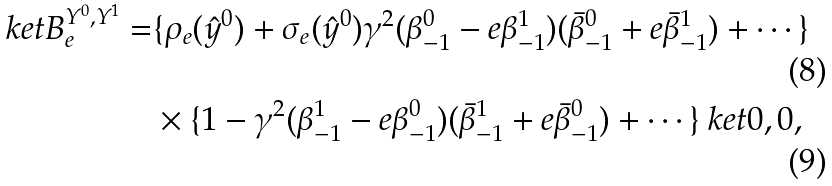<formula> <loc_0><loc_0><loc_500><loc_500>\ k e t { B } _ { e } ^ { Y ^ { 0 } , Y ^ { 1 } } = & \{ \rho _ { e } ( \hat { y } ^ { 0 } ) + \sigma _ { e } ( \hat { y } ^ { 0 } ) \gamma ^ { 2 } ( \beta _ { - 1 } ^ { 0 } - e \beta _ { - 1 } ^ { 1 } ) ( \bar { \beta } _ { - 1 } ^ { 0 } + e \bar { \beta } _ { - 1 } ^ { 1 } ) + \cdots \} \\ & \times \{ 1 - \gamma ^ { 2 } ( \beta _ { - 1 } ^ { 1 } - e \beta _ { - 1 } ^ { 0 } ) ( \bar { \beta } _ { - 1 } ^ { 1 } + e \bar { \beta } _ { - 1 } ^ { 0 } ) + \cdots \} \ k e t { 0 , 0 } ,</formula> 